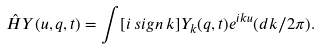<formula> <loc_0><loc_0><loc_500><loc_500>\hat { H } Y ( u , q , t ) = \int [ i \, s i g n \, k ] Y _ { k } ( q , t ) e ^ { i k u } ( { d k } / { 2 \pi } ) .</formula> 